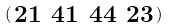<formula> <loc_0><loc_0><loc_500><loc_500>\begin{psmallmatrix} 2 1 & 4 1 & 4 4 & 2 3 \end{psmallmatrix}</formula> 